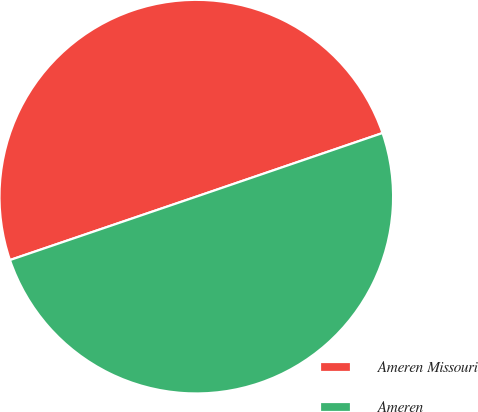Convert chart. <chart><loc_0><loc_0><loc_500><loc_500><pie_chart><fcel>Ameren Missouri<fcel>Ameren<nl><fcel>49.98%<fcel>50.02%<nl></chart> 